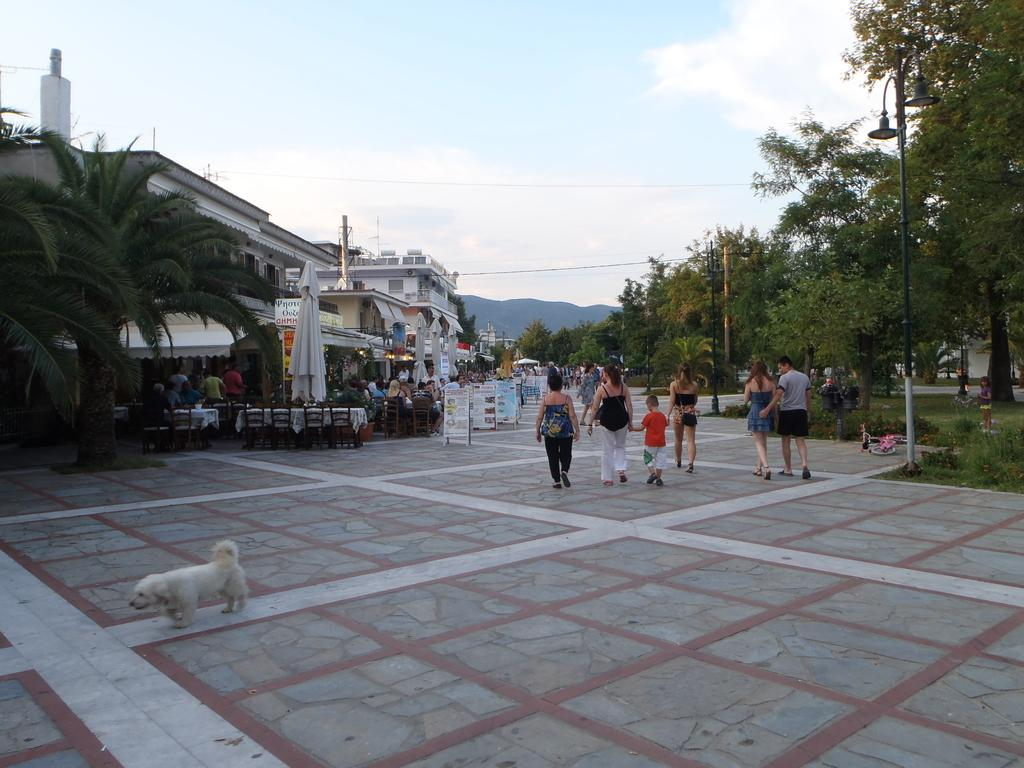How many people are in the image? There are people in the image, but the exact number is not specified. What type of natural elements can be seen in the image? There are trees in the image. What type of man-made structures are visible in the image? There are buildings in the image. What type of decorations are present in the image? There are banners in the image. What type of animal is in the image? There is a dog in the image. What type of furniture is in the image? There are chairs and tables in the image. What part of the natural environment is visible in the image? The sky is visible in the image. How many cats are sitting on the tables in the image? There are no cats present in the image; only a dog is mentioned. What type of insect can be seen crawling on the banners in the image? There is no insect mentioned or visible in the image. 